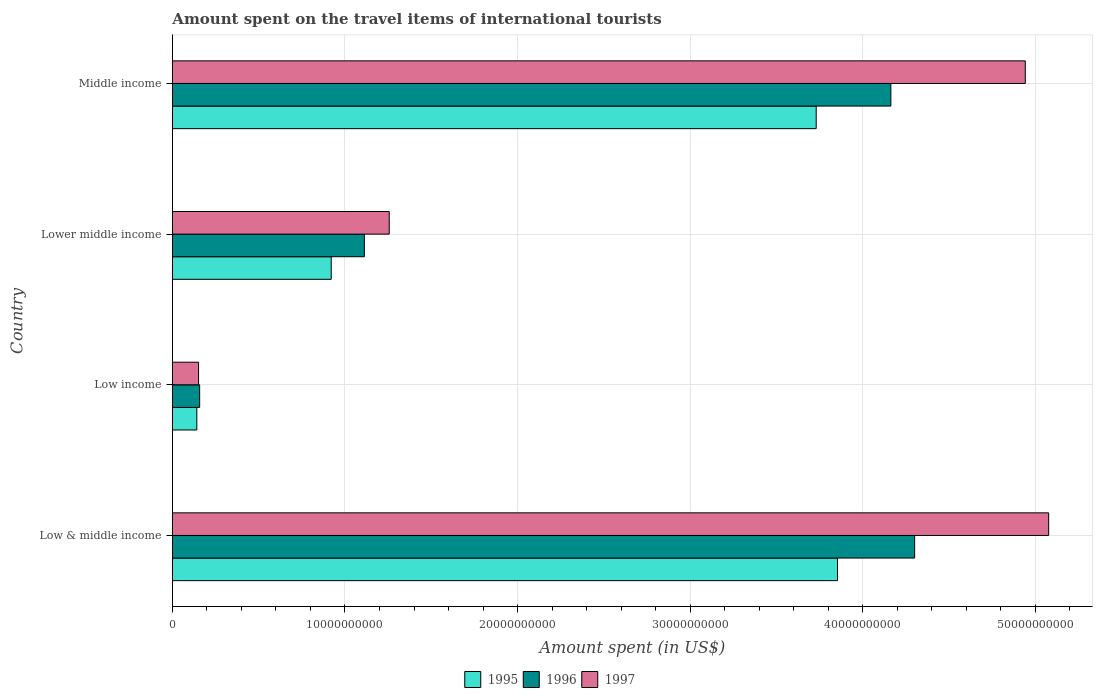Are the number of bars on each tick of the Y-axis equal?
Give a very brief answer. Yes. What is the label of the 2nd group of bars from the top?
Your answer should be very brief. Lower middle income. What is the amount spent on the travel items of international tourists in 1997 in Lower middle income?
Keep it short and to the point. 1.26e+1. Across all countries, what is the maximum amount spent on the travel items of international tourists in 1995?
Ensure brevity in your answer.  3.85e+1. Across all countries, what is the minimum amount spent on the travel items of international tourists in 1996?
Your answer should be very brief. 1.58e+09. What is the total amount spent on the travel items of international tourists in 1997 in the graph?
Ensure brevity in your answer.  1.14e+11. What is the difference between the amount spent on the travel items of international tourists in 1995 in Low & middle income and that in Low income?
Provide a short and direct response. 3.71e+1. What is the difference between the amount spent on the travel items of international tourists in 1997 in Middle income and the amount spent on the travel items of international tourists in 1995 in Low income?
Your response must be concise. 4.80e+1. What is the average amount spent on the travel items of international tourists in 1996 per country?
Provide a short and direct response. 2.43e+1. What is the difference between the amount spent on the travel items of international tourists in 1996 and amount spent on the travel items of international tourists in 1995 in Low income?
Keep it short and to the point. 1.63e+08. What is the ratio of the amount spent on the travel items of international tourists in 1997 in Lower middle income to that in Middle income?
Offer a very short reply. 0.25. What is the difference between the highest and the second highest amount spent on the travel items of international tourists in 1997?
Provide a succinct answer. 1.36e+09. What is the difference between the highest and the lowest amount spent on the travel items of international tourists in 1995?
Provide a short and direct response. 3.71e+1. What does the 1st bar from the bottom in Lower middle income represents?
Provide a short and direct response. 1995. Is it the case that in every country, the sum of the amount spent on the travel items of international tourists in 1997 and amount spent on the travel items of international tourists in 1996 is greater than the amount spent on the travel items of international tourists in 1995?
Provide a short and direct response. Yes. How many bars are there?
Make the answer very short. 12. What is the difference between two consecutive major ticks on the X-axis?
Keep it short and to the point. 1.00e+1. Are the values on the major ticks of X-axis written in scientific E-notation?
Ensure brevity in your answer.  No. Does the graph contain grids?
Your response must be concise. Yes. How many legend labels are there?
Your response must be concise. 3. What is the title of the graph?
Provide a succinct answer. Amount spent on the travel items of international tourists. Does "1985" appear as one of the legend labels in the graph?
Your answer should be compact. No. What is the label or title of the X-axis?
Offer a very short reply. Amount spent (in US$). What is the label or title of the Y-axis?
Your answer should be very brief. Country. What is the Amount spent (in US$) in 1995 in Low & middle income?
Your answer should be very brief. 3.85e+1. What is the Amount spent (in US$) of 1996 in Low & middle income?
Offer a terse response. 4.30e+1. What is the Amount spent (in US$) of 1997 in Low & middle income?
Give a very brief answer. 5.08e+1. What is the Amount spent (in US$) of 1995 in Low income?
Make the answer very short. 1.42e+09. What is the Amount spent (in US$) of 1996 in Low income?
Make the answer very short. 1.58e+09. What is the Amount spent (in US$) of 1997 in Low income?
Offer a terse response. 1.52e+09. What is the Amount spent (in US$) in 1995 in Lower middle income?
Your answer should be very brief. 9.20e+09. What is the Amount spent (in US$) in 1996 in Lower middle income?
Ensure brevity in your answer.  1.11e+1. What is the Amount spent (in US$) in 1997 in Lower middle income?
Provide a succinct answer. 1.26e+1. What is the Amount spent (in US$) in 1995 in Middle income?
Your answer should be compact. 3.73e+1. What is the Amount spent (in US$) of 1996 in Middle income?
Your response must be concise. 4.16e+1. What is the Amount spent (in US$) in 1997 in Middle income?
Make the answer very short. 4.94e+1. Across all countries, what is the maximum Amount spent (in US$) in 1995?
Ensure brevity in your answer.  3.85e+1. Across all countries, what is the maximum Amount spent (in US$) of 1996?
Make the answer very short. 4.30e+1. Across all countries, what is the maximum Amount spent (in US$) of 1997?
Offer a terse response. 5.08e+1. Across all countries, what is the minimum Amount spent (in US$) in 1995?
Provide a short and direct response. 1.42e+09. Across all countries, what is the minimum Amount spent (in US$) in 1996?
Keep it short and to the point. 1.58e+09. Across all countries, what is the minimum Amount spent (in US$) of 1997?
Offer a very short reply. 1.52e+09. What is the total Amount spent (in US$) of 1995 in the graph?
Keep it short and to the point. 8.65e+1. What is the total Amount spent (in US$) in 1996 in the graph?
Offer a very short reply. 9.73e+1. What is the total Amount spent (in US$) in 1997 in the graph?
Make the answer very short. 1.14e+11. What is the difference between the Amount spent (in US$) in 1995 in Low & middle income and that in Low income?
Ensure brevity in your answer.  3.71e+1. What is the difference between the Amount spent (in US$) in 1996 in Low & middle income and that in Low income?
Your response must be concise. 4.14e+1. What is the difference between the Amount spent (in US$) of 1997 in Low & middle income and that in Low income?
Offer a very short reply. 4.93e+1. What is the difference between the Amount spent (in US$) in 1995 in Low & middle income and that in Lower middle income?
Your response must be concise. 2.93e+1. What is the difference between the Amount spent (in US$) in 1996 in Low & middle income and that in Lower middle income?
Make the answer very short. 3.19e+1. What is the difference between the Amount spent (in US$) in 1997 in Low & middle income and that in Lower middle income?
Provide a short and direct response. 3.82e+1. What is the difference between the Amount spent (in US$) of 1995 in Low & middle income and that in Middle income?
Ensure brevity in your answer.  1.24e+09. What is the difference between the Amount spent (in US$) of 1996 in Low & middle income and that in Middle income?
Ensure brevity in your answer.  1.38e+09. What is the difference between the Amount spent (in US$) in 1997 in Low & middle income and that in Middle income?
Your answer should be compact. 1.36e+09. What is the difference between the Amount spent (in US$) of 1995 in Low income and that in Lower middle income?
Ensure brevity in your answer.  -7.79e+09. What is the difference between the Amount spent (in US$) of 1996 in Low income and that in Lower middle income?
Keep it short and to the point. -9.54e+09. What is the difference between the Amount spent (in US$) in 1997 in Low income and that in Lower middle income?
Your answer should be very brief. -1.10e+1. What is the difference between the Amount spent (in US$) in 1995 in Low income and that in Middle income?
Your response must be concise. -3.59e+1. What is the difference between the Amount spent (in US$) in 1996 in Low income and that in Middle income?
Give a very brief answer. -4.00e+1. What is the difference between the Amount spent (in US$) of 1997 in Low income and that in Middle income?
Your answer should be compact. -4.79e+1. What is the difference between the Amount spent (in US$) in 1995 in Lower middle income and that in Middle income?
Offer a terse response. -2.81e+1. What is the difference between the Amount spent (in US$) in 1996 in Lower middle income and that in Middle income?
Offer a terse response. -3.05e+1. What is the difference between the Amount spent (in US$) of 1997 in Lower middle income and that in Middle income?
Your answer should be compact. -3.69e+1. What is the difference between the Amount spent (in US$) of 1995 in Low & middle income and the Amount spent (in US$) of 1996 in Low income?
Your response must be concise. 3.70e+1. What is the difference between the Amount spent (in US$) in 1995 in Low & middle income and the Amount spent (in US$) in 1997 in Low income?
Give a very brief answer. 3.70e+1. What is the difference between the Amount spent (in US$) of 1996 in Low & middle income and the Amount spent (in US$) of 1997 in Low income?
Provide a short and direct response. 4.15e+1. What is the difference between the Amount spent (in US$) of 1995 in Low & middle income and the Amount spent (in US$) of 1996 in Lower middle income?
Offer a terse response. 2.74e+1. What is the difference between the Amount spent (in US$) of 1995 in Low & middle income and the Amount spent (in US$) of 1997 in Lower middle income?
Your answer should be compact. 2.60e+1. What is the difference between the Amount spent (in US$) of 1996 in Low & middle income and the Amount spent (in US$) of 1997 in Lower middle income?
Provide a short and direct response. 3.04e+1. What is the difference between the Amount spent (in US$) of 1995 in Low & middle income and the Amount spent (in US$) of 1996 in Middle income?
Offer a very short reply. -3.09e+09. What is the difference between the Amount spent (in US$) in 1995 in Low & middle income and the Amount spent (in US$) in 1997 in Middle income?
Give a very brief answer. -1.09e+1. What is the difference between the Amount spent (in US$) in 1996 in Low & middle income and the Amount spent (in US$) in 1997 in Middle income?
Your answer should be compact. -6.41e+09. What is the difference between the Amount spent (in US$) of 1995 in Low income and the Amount spent (in US$) of 1996 in Lower middle income?
Make the answer very short. -9.71e+09. What is the difference between the Amount spent (in US$) in 1995 in Low income and the Amount spent (in US$) in 1997 in Lower middle income?
Keep it short and to the point. -1.11e+1. What is the difference between the Amount spent (in US$) of 1996 in Low income and the Amount spent (in US$) of 1997 in Lower middle income?
Your response must be concise. -1.10e+1. What is the difference between the Amount spent (in US$) in 1995 in Low income and the Amount spent (in US$) in 1996 in Middle income?
Offer a terse response. -4.02e+1. What is the difference between the Amount spent (in US$) of 1995 in Low income and the Amount spent (in US$) of 1997 in Middle income?
Your response must be concise. -4.80e+1. What is the difference between the Amount spent (in US$) in 1996 in Low income and the Amount spent (in US$) in 1997 in Middle income?
Your answer should be very brief. -4.78e+1. What is the difference between the Amount spent (in US$) of 1995 in Lower middle income and the Amount spent (in US$) of 1996 in Middle income?
Offer a very short reply. -3.24e+1. What is the difference between the Amount spent (in US$) of 1995 in Lower middle income and the Amount spent (in US$) of 1997 in Middle income?
Provide a short and direct response. -4.02e+1. What is the difference between the Amount spent (in US$) in 1996 in Lower middle income and the Amount spent (in US$) in 1997 in Middle income?
Give a very brief answer. -3.83e+1. What is the average Amount spent (in US$) of 1995 per country?
Your answer should be very brief. 2.16e+1. What is the average Amount spent (in US$) in 1996 per country?
Your answer should be very brief. 2.43e+1. What is the average Amount spent (in US$) of 1997 per country?
Provide a short and direct response. 2.86e+1. What is the difference between the Amount spent (in US$) in 1995 and Amount spent (in US$) in 1996 in Low & middle income?
Provide a succinct answer. -4.47e+09. What is the difference between the Amount spent (in US$) in 1995 and Amount spent (in US$) in 1997 in Low & middle income?
Your answer should be very brief. -1.22e+1. What is the difference between the Amount spent (in US$) of 1996 and Amount spent (in US$) of 1997 in Low & middle income?
Provide a short and direct response. -7.77e+09. What is the difference between the Amount spent (in US$) of 1995 and Amount spent (in US$) of 1996 in Low income?
Your response must be concise. -1.63e+08. What is the difference between the Amount spent (in US$) in 1995 and Amount spent (in US$) in 1997 in Low income?
Offer a terse response. -1.00e+08. What is the difference between the Amount spent (in US$) in 1996 and Amount spent (in US$) in 1997 in Low income?
Your answer should be very brief. 6.31e+07. What is the difference between the Amount spent (in US$) in 1995 and Amount spent (in US$) in 1996 in Lower middle income?
Offer a very short reply. -1.92e+09. What is the difference between the Amount spent (in US$) of 1995 and Amount spent (in US$) of 1997 in Lower middle income?
Your response must be concise. -3.36e+09. What is the difference between the Amount spent (in US$) in 1996 and Amount spent (in US$) in 1997 in Lower middle income?
Give a very brief answer. -1.44e+09. What is the difference between the Amount spent (in US$) in 1995 and Amount spent (in US$) in 1996 in Middle income?
Your response must be concise. -4.33e+09. What is the difference between the Amount spent (in US$) in 1995 and Amount spent (in US$) in 1997 in Middle income?
Offer a very short reply. -1.21e+1. What is the difference between the Amount spent (in US$) in 1996 and Amount spent (in US$) in 1997 in Middle income?
Your answer should be very brief. -7.79e+09. What is the ratio of the Amount spent (in US$) in 1995 in Low & middle income to that in Low income?
Your answer should be very brief. 27.18. What is the ratio of the Amount spent (in US$) in 1996 in Low & middle income to that in Low income?
Your answer should be compact. 27.2. What is the ratio of the Amount spent (in US$) in 1997 in Low & middle income to that in Low income?
Ensure brevity in your answer.  33.45. What is the ratio of the Amount spent (in US$) in 1995 in Low & middle income to that in Lower middle income?
Offer a very short reply. 4.19. What is the ratio of the Amount spent (in US$) of 1996 in Low & middle income to that in Lower middle income?
Your answer should be compact. 3.87. What is the ratio of the Amount spent (in US$) in 1997 in Low & middle income to that in Lower middle income?
Keep it short and to the point. 4.04. What is the ratio of the Amount spent (in US$) of 1995 in Low & middle income to that in Middle income?
Your response must be concise. 1.03. What is the ratio of the Amount spent (in US$) in 1996 in Low & middle income to that in Middle income?
Your answer should be compact. 1.03. What is the ratio of the Amount spent (in US$) in 1997 in Low & middle income to that in Middle income?
Provide a succinct answer. 1.03. What is the ratio of the Amount spent (in US$) of 1995 in Low income to that in Lower middle income?
Provide a succinct answer. 0.15. What is the ratio of the Amount spent (in US$) of 1996 in Low income to that in Lower middle income?
Ensure brevity in your answer.  0.14. What is the ratio of the Amount spent (in US$) of 1997 in Low income to that in Lower middle income?
Offer a terse response. 0.12. What is the ratio of the Amount spent (in US$) of 1995 in Low income to that in Middle income?
Give a very brief answer. 0.04. What is the ratio of the Amount spent (in US$) in 1996 in Low income to that in Middle income?
Provide a succinct answer. 0.04. What is the ratio of the Amount spent (in US$) of 1997 in Low income to that in Middle income?
Make the answer very short. 0.03. What is the ratio of the Amount spent (in US$) in 1995 in Lower middle income to that in Middle income?
Your answer should be very brief. 0.25. What is the ratio of the Amount spent (in US$) of 1996 in Lower middle income to that in Middle income?
Your answer should be very brief. 0.27. What is the ratio of the Amount spent (in US$) in 1997 in Lower middle income to that in Middle income?
Your answer should be very brief. 0.25. What is the difference between the highest and the second highest Amount spent (in US$) in 1995?
Provide a succinct answer. 1.24e+09. What is the difference between the highest and the second highest Amount spent (in US$) in 1996?
Ensure brevity in your answer.  1.38e+09. What is the difference between the highest and the second highest Amount spent (in US$) in 1997?
Your answer should be very brief. 1.36e+09. What is the difference between the highest and the lowest Amount spent (in US$) in 1995?
Your response must be concise. 3.71e+1. What is the difference between the highest and the lowest Amount spent (in US$) in 1996?
Your answer should be very brief. 4.14e+1. What is the difference between the highest and the lowest Amount spent (in US$) in 1997?
Make the answer very short. 4.93e+1. 